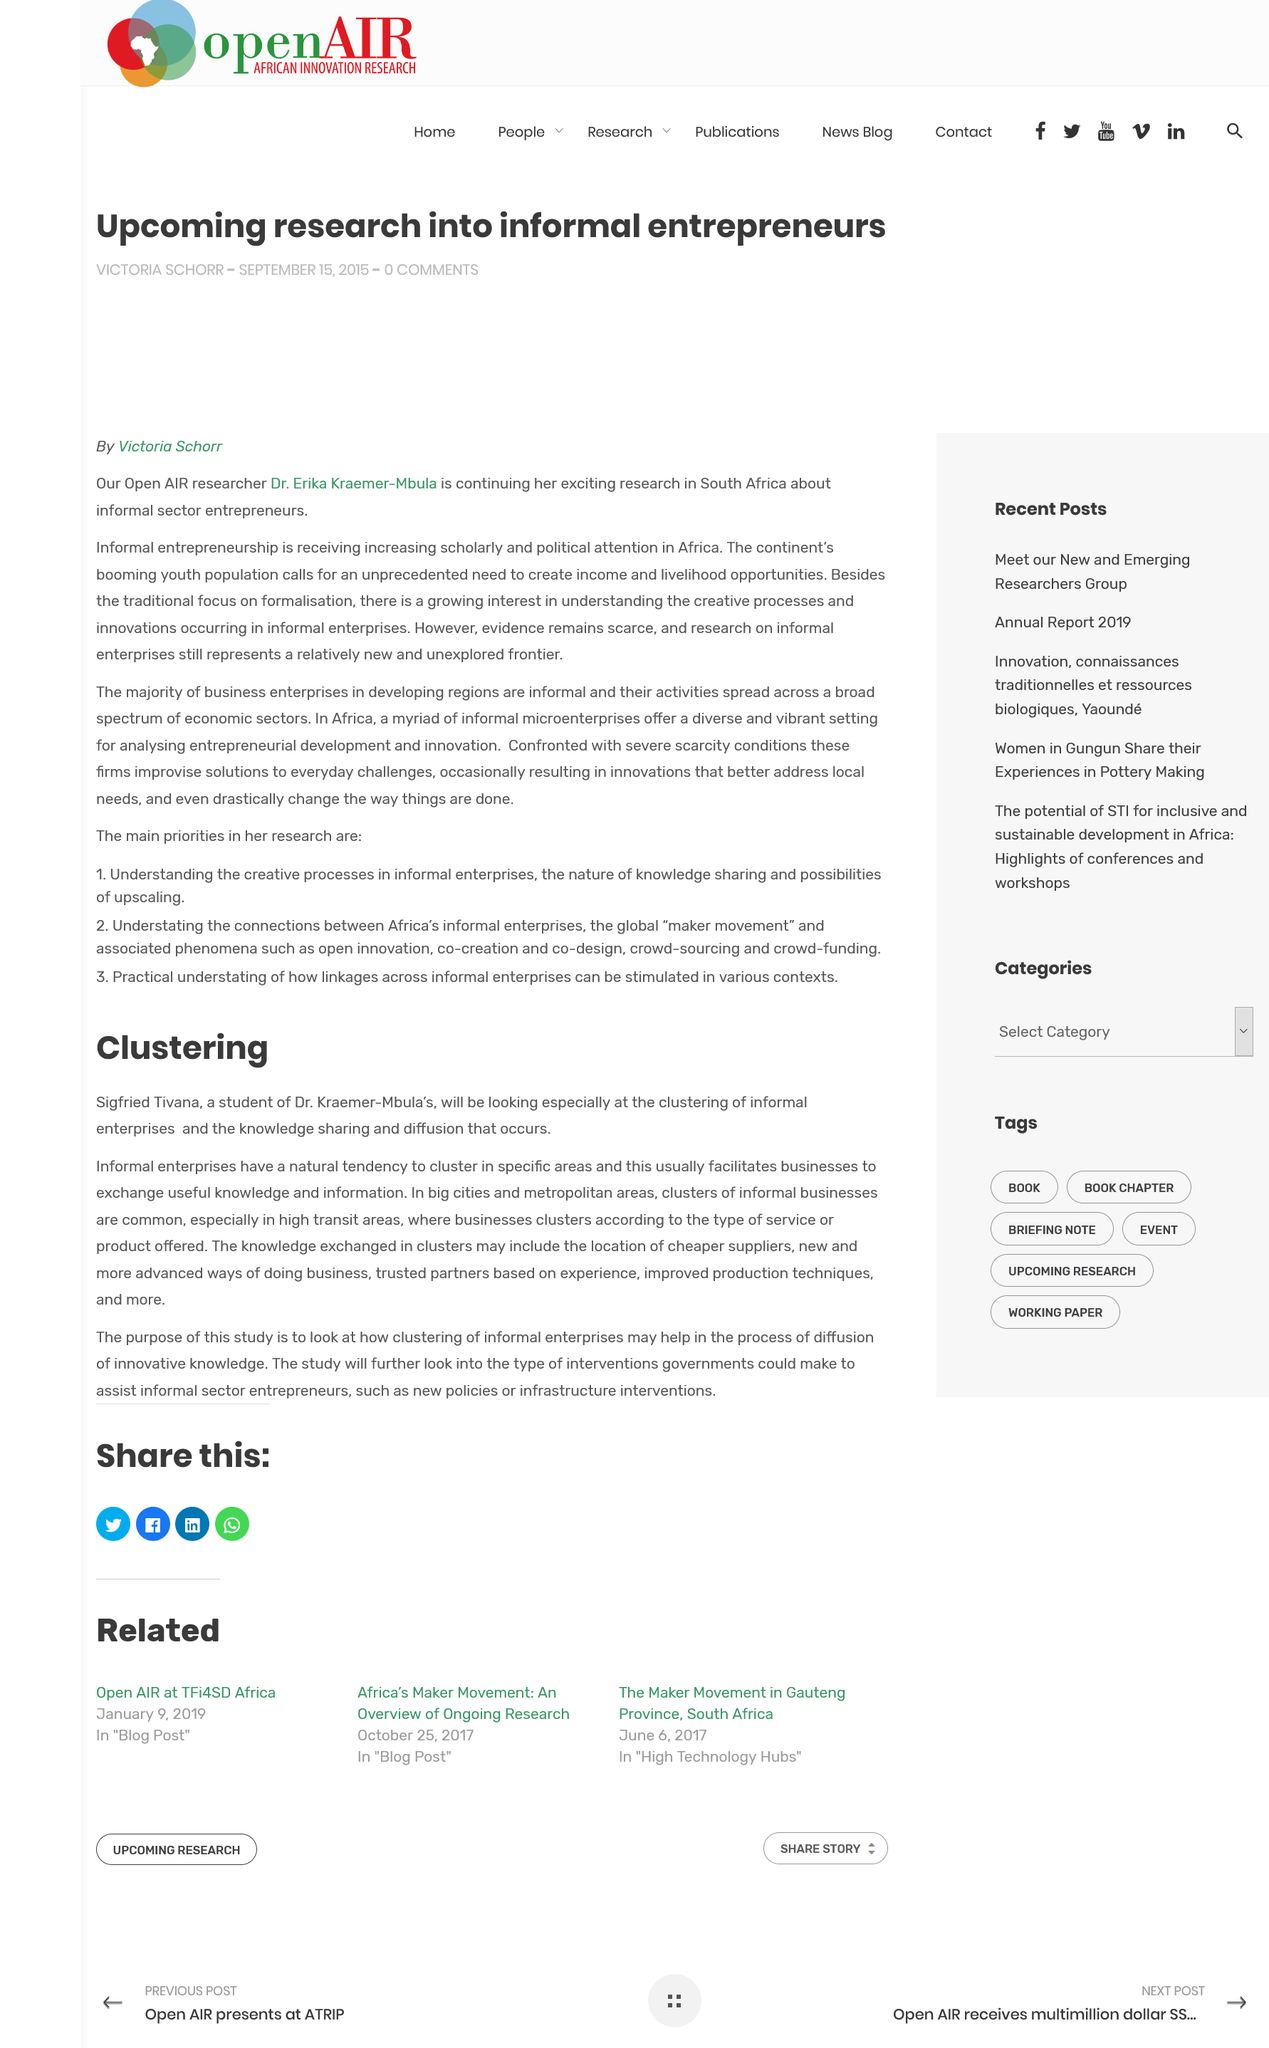Outline some significant characteristics in this image. The doctor mentioned in the article "Clustering" is Dr. Kraemer-Mbula. The clustering of informal enterprises and the knowledge sharing and diffusion that occurs are being particularly examined in the study. The knowledge exchanged in clusters may include, but is not limited to, the location of cheaper supplies, new and advanced ways of doing business, trusted partners based on experience, improved production techniques, and more. 